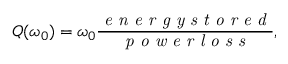Convert formula to latex. <formula><loc_0><loc_0><loc_500><loc_500>Q ( \omega _ { 0 } ) = \omega _ { 0 } \frac { e n e r g y s t o r e d } { p o w e r l o s s } ,</formula> 